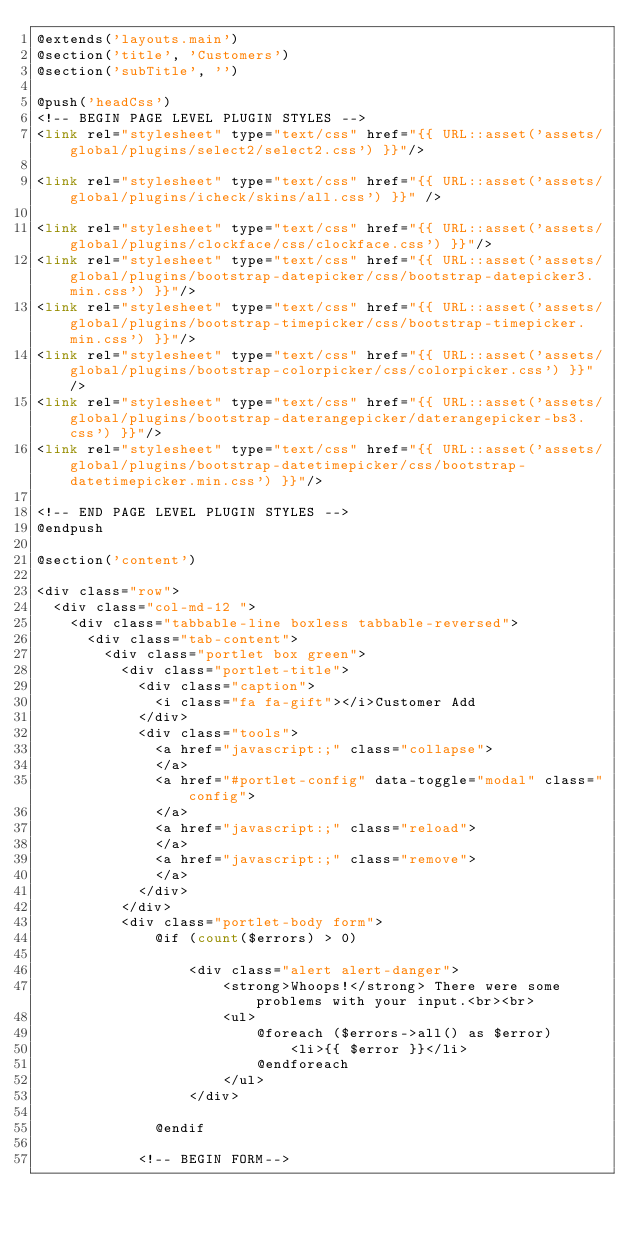Convert code to text. <code><loc_0><loc_0><loc_500><loc_500><_PHP_>@extends('layouts.main')
@section('title', 'Customers')
@section('subTitle', '')

@push('headCss')
<!-- BEGIN PAGE LEVEL PLUGIN STYLES -->
<link rel="stylesheet" type="text/css" href="{{ URL::asset('assets/global/plugins/select2/select2.css') }}"/>

<link rel="stylesheet" type="text/css" href="{{ URL::asset('assets/global/plugins/icheck/skins/all.css') }}" />

<link rel="stylesheet" type="text/css" href="{{ URL::asset('assets/global/plugins/clockface/css/clockface.css') }}"/>
<link rel="stylesheet" type="text/css" href="{{ URL::asset('assets/global/plugins/bootstrap-datepicker/css/bootstrap-datepicker3.min.css') }}"/>
<link rel="stylesheet" type="text/css" href="{{ URL::asset('assets/global/plugins/bootstrap-timepicker/css/bootstrap-timepicker.min.css') }}"/>
<link rel="stylesheet" type="text/css" href="{{ URL::asset('assets/global/plugins/bootstrap-colorpicker/css/colorpicker.css') }}"/>
<link rel="stylesheet" type="text/css" href="{{ URL::asset('assets/global/plugins/bootstrap-daterangepicker/daterangepicker-bs3.css') }}"/>
<link rel="stylesheet" type="text/css" href="{{ URL::asset('assets/global/plugins/bootstrap-datetimepicker/css/bootstrap-datetimepicker.min.css') }}"/>

<!-- END PAGE LEVEL PLUGIN STYLES -->
@endpush

@section('content')

<div class="row">
	<div class="col-md-12 ">
		<div class="tabbable-line boxless tabbable-reversed">
			<div class="tab-content">
				<div class="portlet box green">
					<div class="portlet-title">
						<div class="caption">
							<i class="fa fa-gift"></i>Customer Add
						</div>
						<div class="tools">
							<a href="javascript:;" class="collapse">
							</a>
							<a href="#portlet-config" data-toggle="modal" class="config">
							</a>
							<a href="javascript:;" class="reload">
							</a>
							<a href="javascript:;" class="remove">
							</a>
						</div>
					</div>
					<div class="portlet-body form">
					    @if (count($errors) > 0)
					       
					      	<div class="alert alert-danger">
					            <strong>Whoops!</strong> There were some problems with your input.<br><br>
					            <ul>
					                @foreach ($errors->all() as $error)
					                    <li>{{ $error }}</li>
					                @endforeach
					            </ul>
					        </div>
					        
					    @endif

						<!-- BEGIN FORM--></code> 